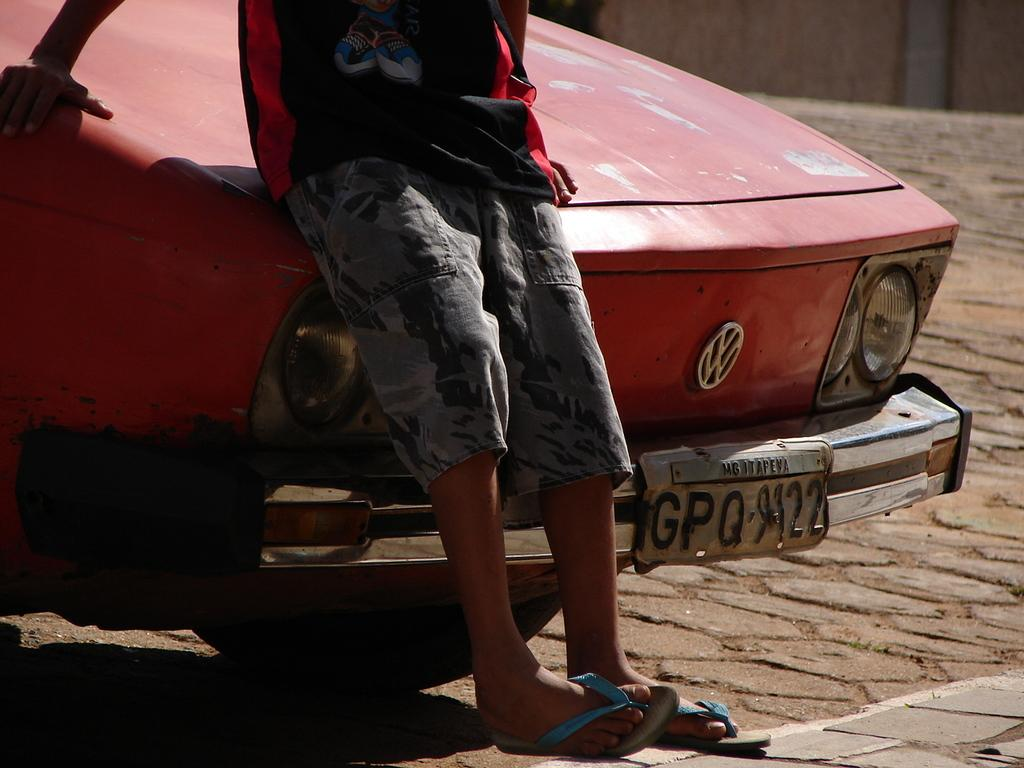Who is present in the image? There is a man in the image. What is the man doing in the image? The man is standing and leaning on a car. Where is the car located in relation to the man? The car is behind the man. What is the color of the car? The car is red in color. What type of brush is the man using to paint the corn in the image? There is no brush or corn present in the image. What kind of coach is the man driving in the image? There is no coach or driving activity depicted in the image. 